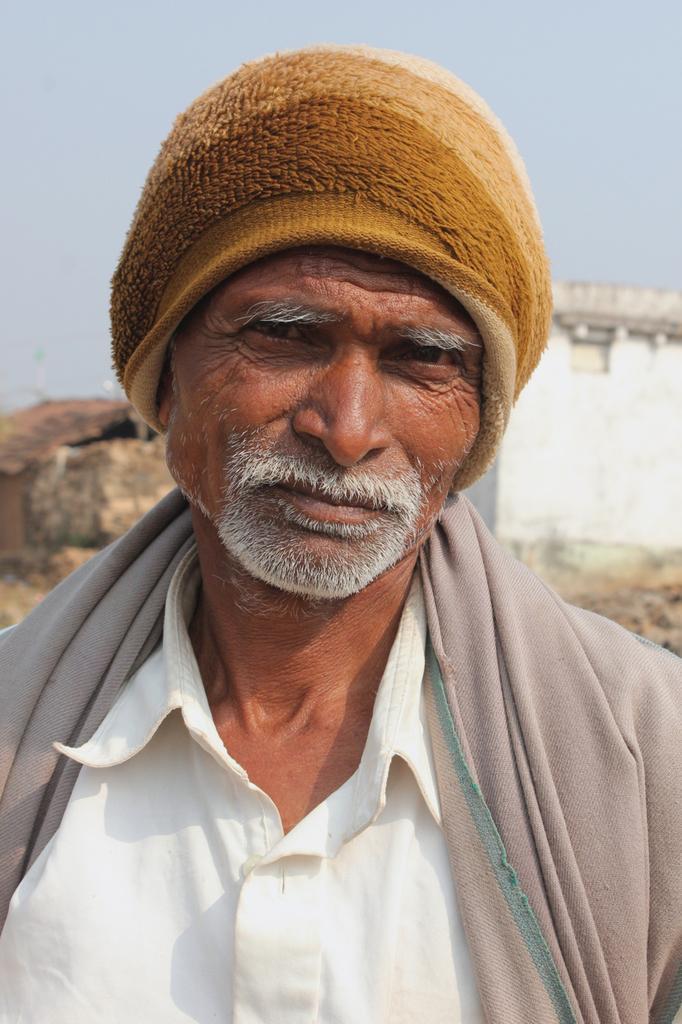Could you give a brief overview of what you see in this image? In this image there is a person, wearing a woolen cap, behind him may there is a house, sky visible. 